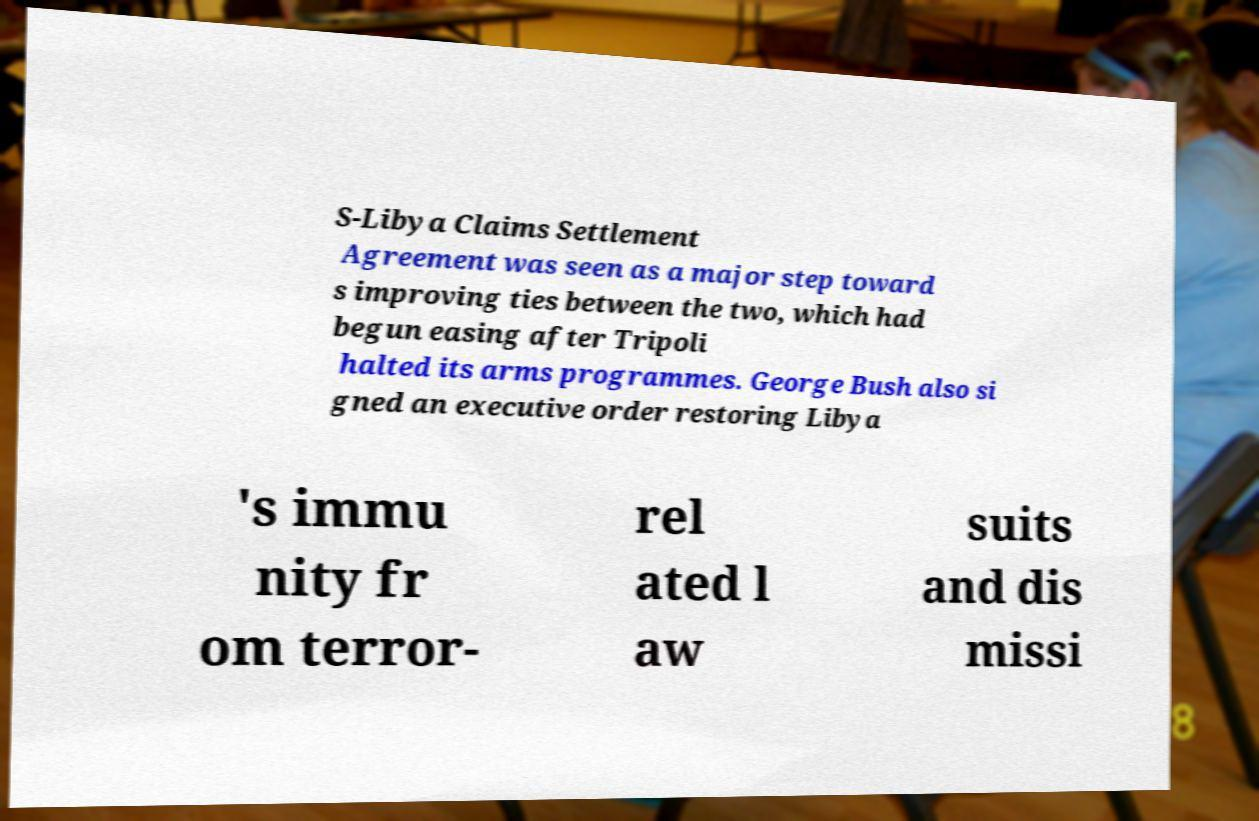There's text embedded in this image that I need extracted. Can you transcribe it verbatim? S-Libya Claims Settlement Agreement was seen as a major step toward s improving ties between the two, which had begun easing after Tripoli halted its arms programmes. George Bush also si gned an executive order restoring Libya 's immu nity fr om terror- rel ated l aw suits and dis missi 